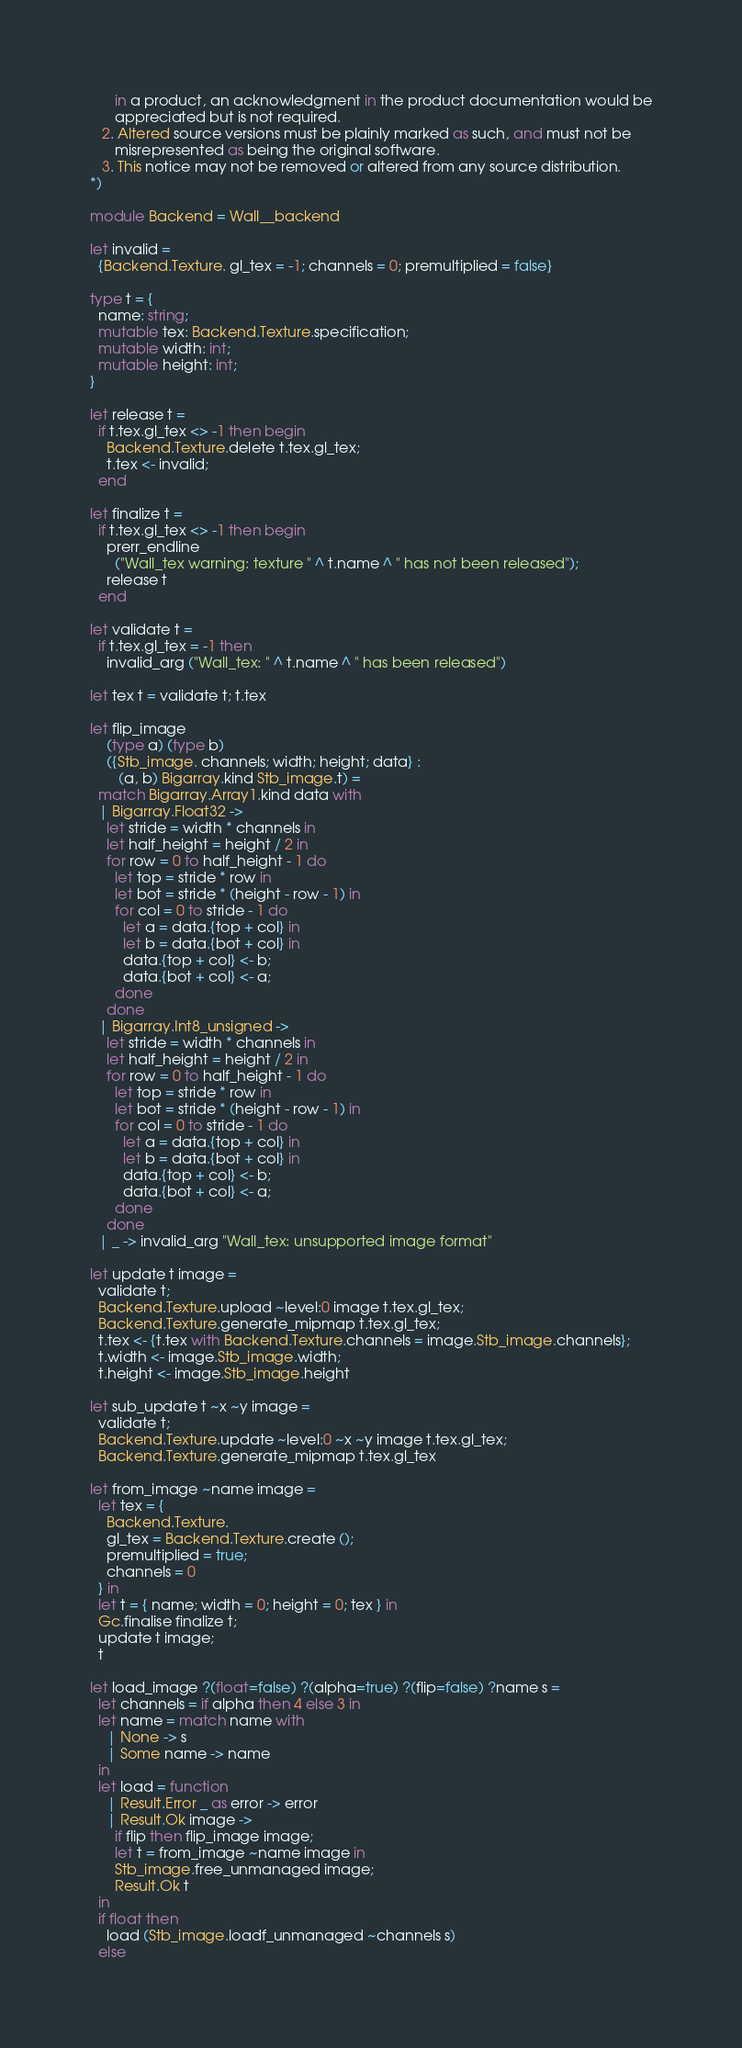<code> <loc_0><loc_0><loc_500><loc_500><_OCaml_>      in a product, an acknowledgment in the product documentation would be
      appreciated but is not required.
   2. Altered source versions must be plainly marked as such, and must not be
      misrepresented as being the original software.
   3. This notice may not be removed or altered from any source distribution.
*)

module Backend = Wall__backend

let invalid =
  {Backend.Texture. gl_tex = -1; channels = 0; premultiplied = false}

type t = {
  name: string;
  mutable tex: Backend.Texture.specification;
  mutable width: int;
  mutable height: int;
}

let release t =
  if t.tex.gl_tex <> -1 then begin
    Backend.Texture.delete t.tex.gl_tex;
    t.tex <- invalid;
  end

let finalize t =
  if t.tex.gl_tex <> -1 then begin
    prerr_endline
      ("Wall_tex warning: texture " ^ t.name ^ " has not been released");
    release t
  end

let validate t =
  if t.tex.gl_tex = -1 then
    invalid_arg ("Wall_tex: " ^ t.name ^ " has been released")

let tex t = validate t; t.tex

let flip_image
    (type a) (type b)
    ({Stb_image. channels; width; height; data} :
       (a, b) Bigarray.kind Stb_image.t) =
  match Bigarray.Array1.kind data with
  | Bigarray.Float32 ->
    let stride = width * channels in
    let half_height = height / 2 in
    for row = 0 to half_height - 1 do
      let top = stride * row in
      let bot = stride * (height - row - 1) in
      for col = 0 to stride - 1 do
        let a = data.{top + col} in
        let b = data.{bot + col} in
        data.{top + col} <- b;
        data.{bot + col} <- a;
      done
    done
  | Bigarray.Int8_unsigned ->
    let stride = width * channels in
    let half_height = height / 2 in
    for row = 0 to half_height - 1 do
      let top = stride * row in
      let bot = stride * (height - row - 1) in
      for col = 0 to stride - 1 do
        let a = data.{top + col} in
        let b = data.{bot + col} in
        data.{top + col} <- b;
        data.{bot + col} <- a;
      done
    done
  | _ -> invalid_arg "Wall_tex: unsupported image format"

let update t image =
  validate t;
  Backend.Texture.upload ~level:0 image t.tex.gl_tex;
  Backend.Texture.generate_mipmap t.tex.gl_tex;
  t.tex <- {t.tex with Backend.Texture.channels = image.Stb_image.channels};
  t.width <- image.Stb_image.width;
  t.height <- image.Stb_image.height

let sub_update t ~x ~y image =
  validate t;
  Backend.Texture.update ~level:0 ~x ~y image t.tex.gl_tex;
  Backend.Texture.generate_mipmap t.tex.gl_tex

let from_image ~name image =
  let tex = {
    Backend.Texture.
    gl_tex = Backend.Texture.create ();
    premultiplied = true;
    channels = 0
  } in
  let t = { name; width = 0; height = 0; tex } in
  Gc.finalise finalize t;
  update t image;
  t

let load_image ?(float=false) ?(alpha=true) ?(flip=false) ?name s =
  let channels = if alpha then 4 else 3 in
  let name = match name with
    | None -> s
    | Some name -> name
  in
  let load = function
    | Result.Error _ as error -> error
    | Result.Ok image ->
      if flip then flip_image image;
      let t = from_image ~name image in
      Stb_image.free_unmanaged image;
      Result.Ok t
  in
  if float then
    load (Stb_image.loadf_unmanaged ~channels s)
  else</code> 